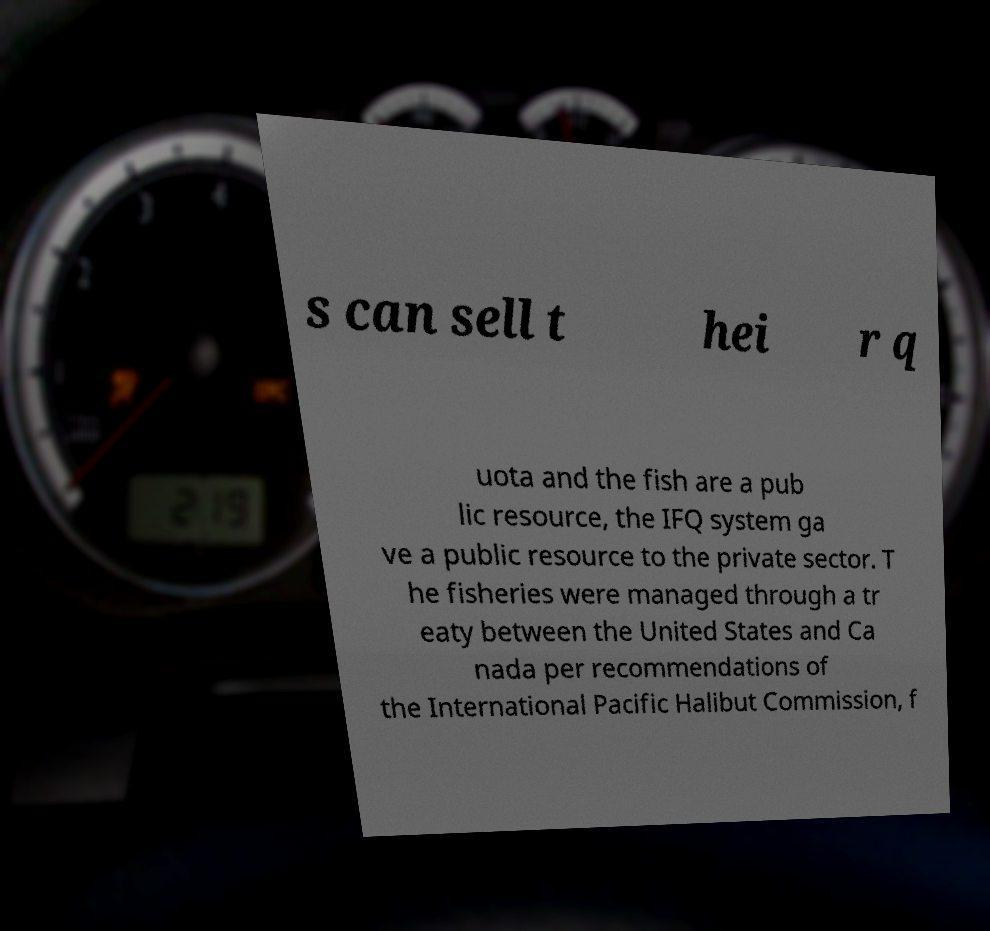Could you assist in decoding the text presented in this image and type it out clearly? s can sell t hei r q uota and the fish are a pub lic resource, the IFQ system ga ve a public resource to the private sector. T he fisheries were managed through a tr eaty between the United States and Ca nada per recommendations of the International Pacific Halibut Commission, f 